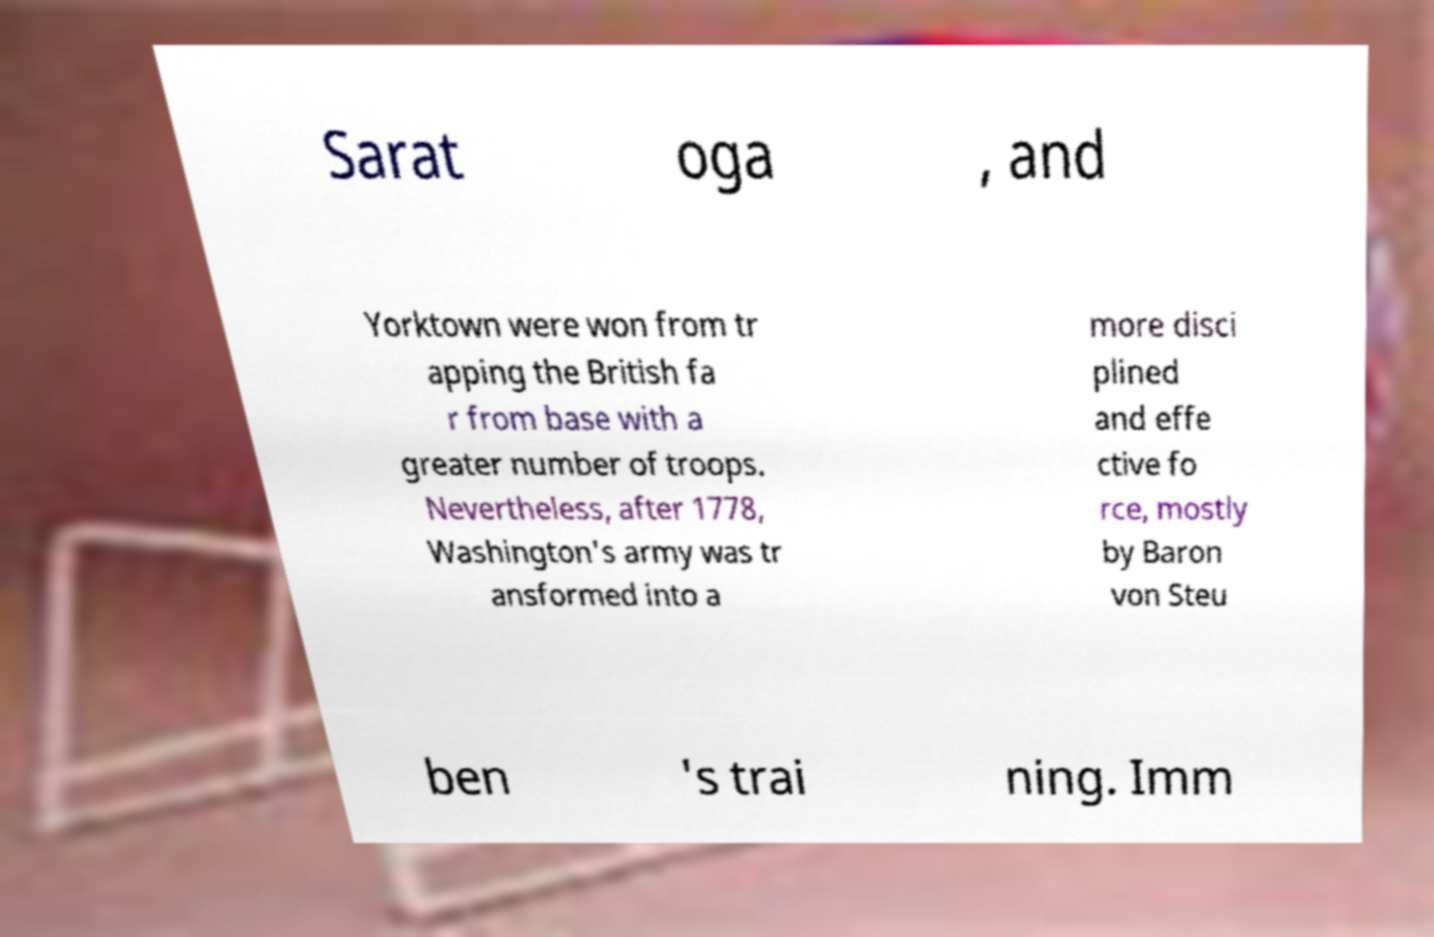I need the written content from this picture converted into text. Can you do that? Sarat oga , and Yorktown were won from tr apping the British fa r from base with a greater number of troops. Nevertheless, after 1778, Washington's army was tr ansformed into a more disci plined and effe ctive fo rce, mostly by Baron von Steu ben 's trai ning. Imm 